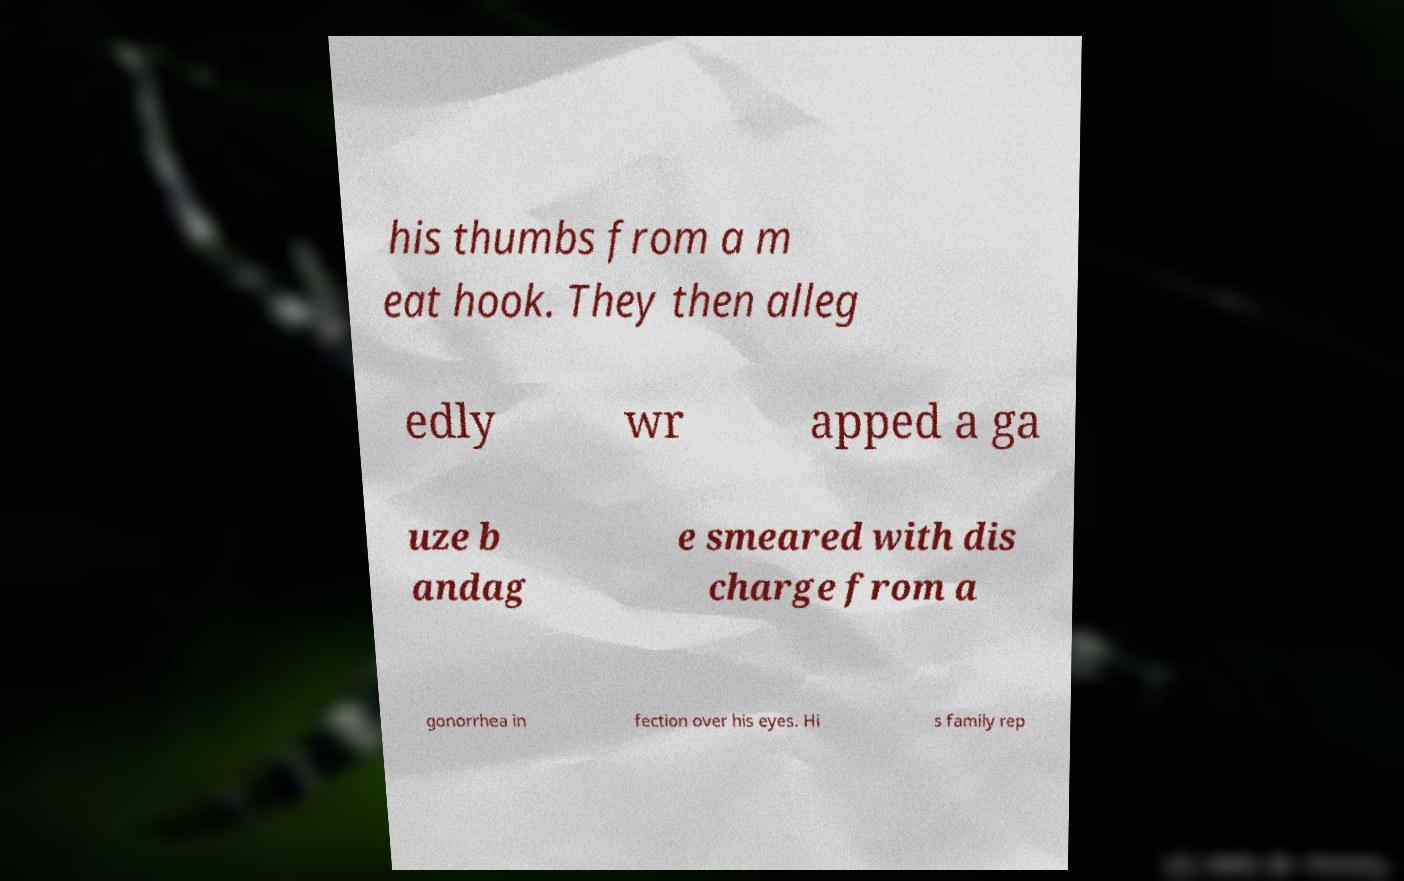Could you extract and type out the text from this image? his thumbs from a m eat hook. They then alleg edly wr apped a ga uze b andag e smeared with dis charge from a gonorrhea in fection over his eyes. Hi s family rep 